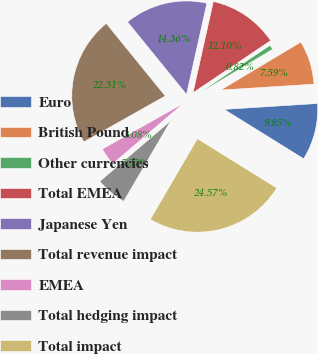Convert chart. <chart><loc_0><loc_0><loc_500><loc_500><pie_chart><fcel>Euro<fcel>British Pound<fcel>Other currencies<fcel>Total EMEA<fcel>Japanese Yen<fcel>Total revenue impact<fcel>EMEA<fcel>Total hedging impact<fcel>Total impact<nl><fcel>9.85%<fcel>7.59%<fcel>0.82%<fcel>12.1%<fcel>14.36%<fcel>22.31%<fcel>3.08%<fcel>5.33%<fcel>24.57%<nl></chart> 